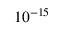<formula> <loc_0><loc_0><loc_500><loc_500>1 0 ^ { - 1 5 }</formula> 